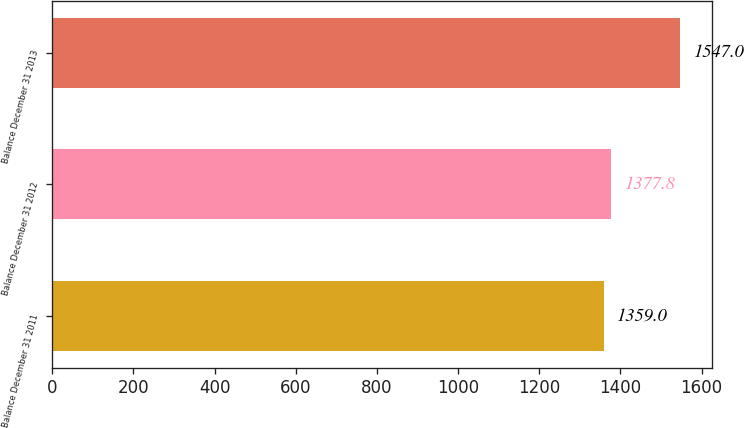Convert chart. <chart><loc_0><loc_0><loc_500><loc_500><bar_chart><fcel>Balance December 31 2011<fcel>Balance December 31 2012<fcel>Balance December 31 2013<nl><fcel>1359<fcel>1377.8<fcel>1547<nl></chart> 